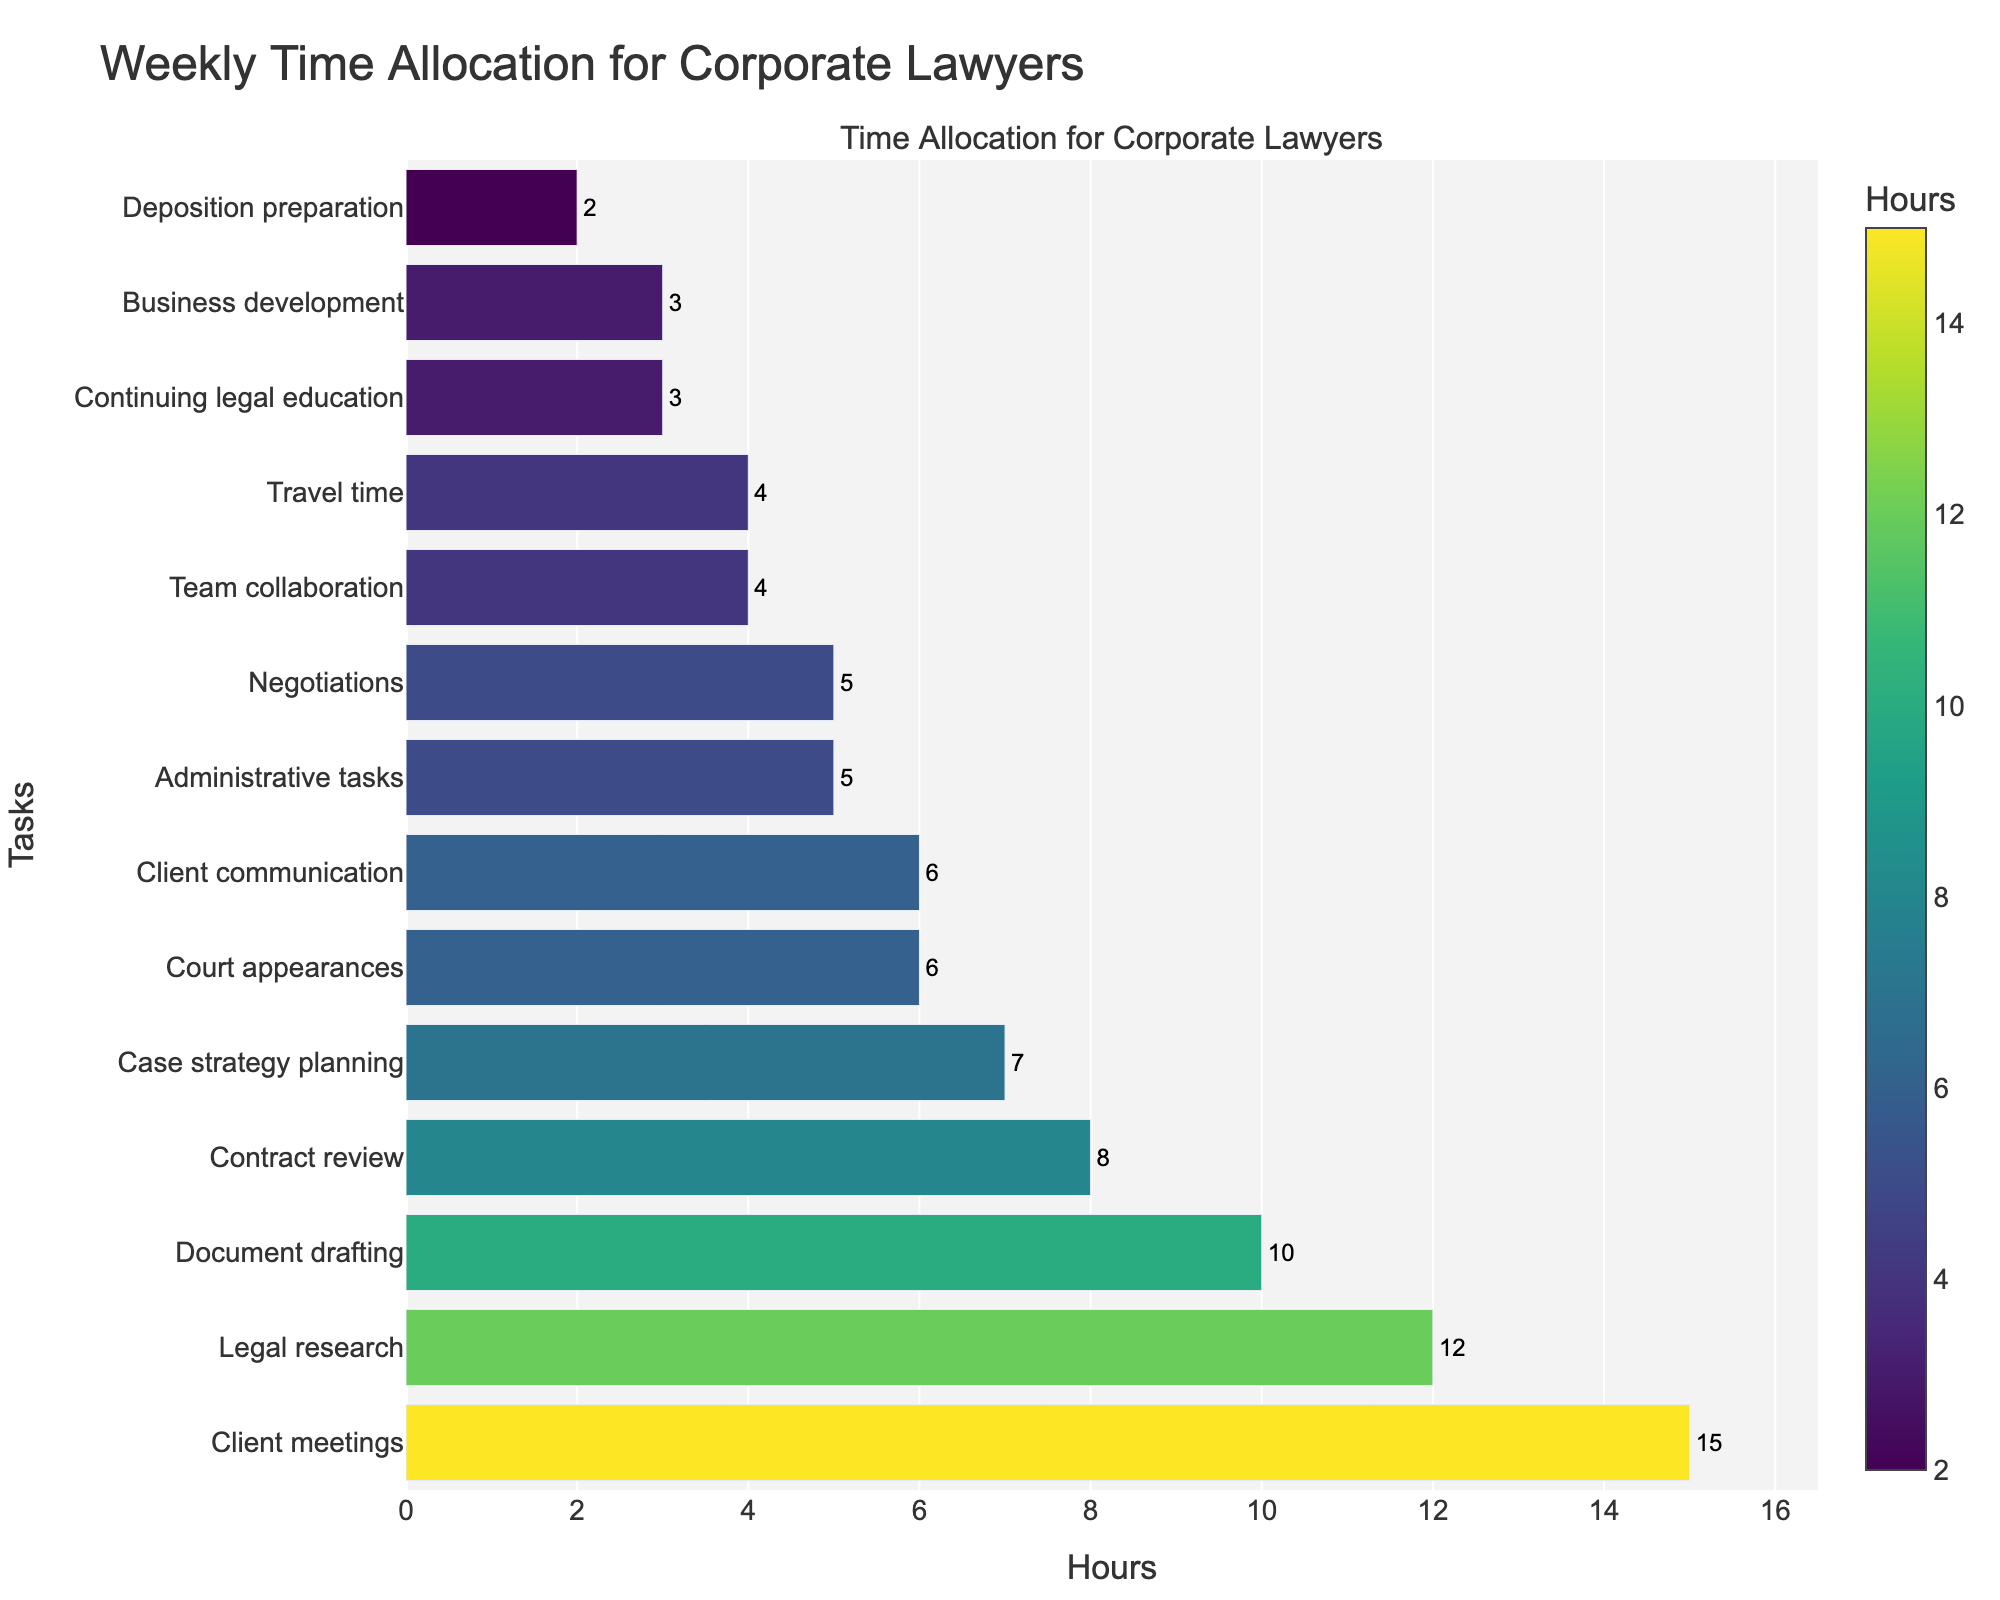What task takes up the most time in a typical workweek for corporate lawyers? Look at the bar that has the longest length. The longest bar represents "Client meetings" with 15 hours.
Answer: Client meetings Which tasks take up the least amount of time in a typical workweek? Look at the two shortest bars. These bars represent "Deposition preparation" and "Continuing legal education" with 2 and 3 hours respectively.
Answer: Deposition preparation and Continuing legal education How much time in total is spent on court appearances, client communication, and travel time? Add the hours for these tasks: Court appearances (6), Client communication (6), and Travel time (4). The total is 6 + 6 + 4 = 16 hours.
Answer: 16 hours Which task takes more time: Document drafting or Negotiations? Compare the lengths of the bars for Document drafting and Negotiations. Document drafting has 10 hours and Negotiations have 5 hours. So, Document drafting takes more time.
Answer: Document drafting What is the difference in hours between the most time-consuming task and the least time-consuming task? The most time-consuming task is "Client meetings" with 15 hours, and the least is "Deposition preparation" with 2 hours. The difference is 15 - 2 = 13 hours.
Answer: 13 hours Is more time spent on administrative tasks or team collaboration? Compare the lengths of the bars for Administrative tasks and Team collaboration. Administrative tasks have 5 hours, while Team collaboration has 4 hours. Therefore, more time is spent on Administrative tasks.
Answer: Administrative tasks What is the total number of hours spent on tasks related to client interaction (Client meetings and Client communication)? Sum the hours for Client meetings (15) and Client communication (6): 15 + 6 = 21 hours.
Answer: 21 hours What is the second most time-consuming task? Identify the bar that is second in length. The second longest bar represents "Legal research" with 12 hours.
Answer: Legal research Compare the total hours spent on Business development and Continuing legal education. Check the bars for Business development (3 hours) and Continuing legal education (3 hours). Both tasks have the same number of hours.
Answer: Equal What is the average number of hours spent on the four least time-consuming tasks? The four least time-consuming tasks are Business development (3), Continuing legal education (3), Team collaboration (4), and Deposition preparation (2). Sum these hours: 3 + 3 + 4 + 2 = 12. Divide by 4 to get the average: 12 / 4 = 3 hours.
Answer: 3 hours 